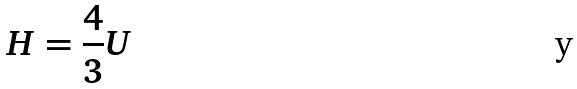Convert formula to latex. <formula><loc_0><loc_0><loc_500><loc_500>H = \frac { 4 } { 3 } U</formula> 